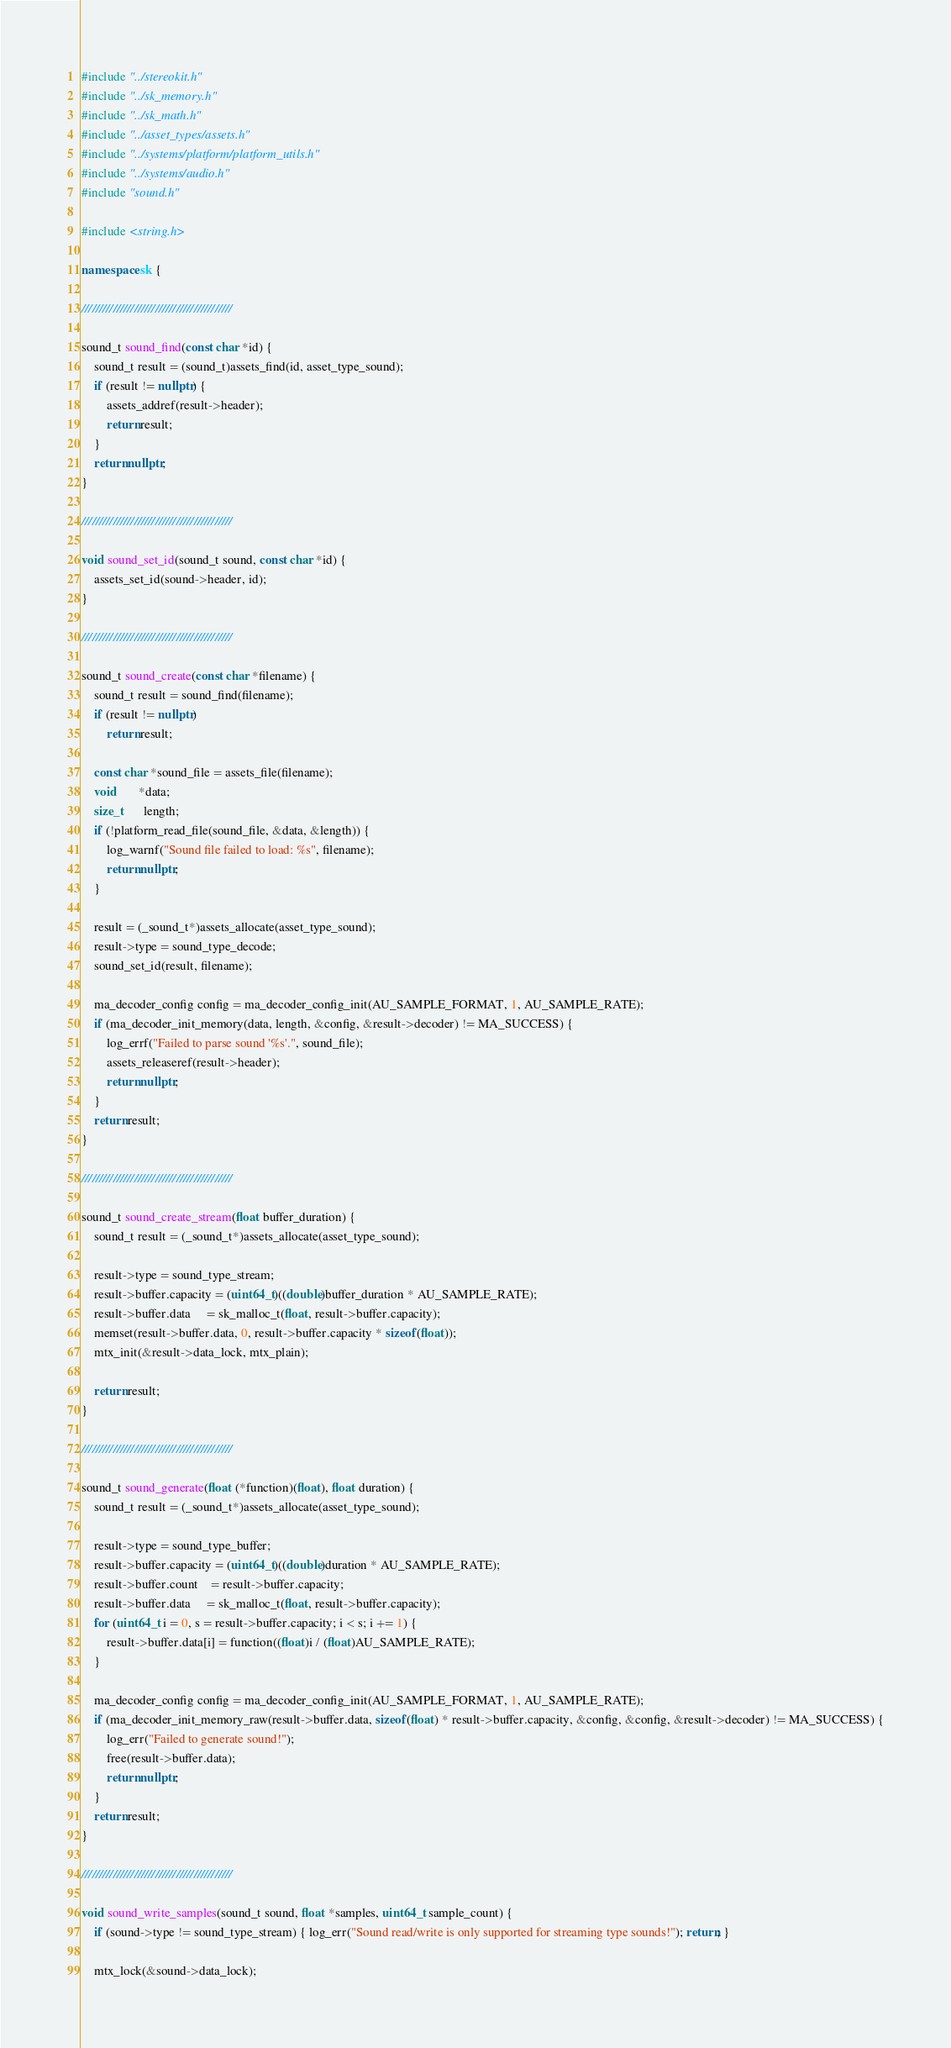Convert code to text. <code><loc_0><loc_0><loc_500><loc_500><_C++_>#include "../stereokit.h"
#include "../sk_memory.h"
#include "../sk_math.h"
#include "../asset_types/assets.h"
#include "../systems/platform/platform_utils.h"
#include "../systems/audio.h"
#include "sound.h"

#include <string.h>

namespace sk {

///////////////////////////////////////////

sound_t sound_find(const char *id) {
	sound_t result = (sound_t)assets_find(id, asset_type_sound);
	if (result != nullptr) {
		assets_addref(result->header);
		return result;
	}
	return nullptr;
}

///////////////////////////////////////////

void sound_set_id(sound_t sound, const char *id) {
	assets_set_id(sound->header, id);
}

///////////////////////////////////////////

sound_t sound_create(const char *filename) {
	sound_t result = sound_find(filename);
	if (result != nullptr)
		return result;

	const char *sound_file = assets_file(filename);
	void       *data;
	size_t      length;
	if (!platform_read_file(sound_file, &data, &length)) {
		log_warnf("Sound file failed to load: %s", filename);
		return nullptr;
	}

	result = (_sound_t*)assets_allocate(asset_type_sound);
	result->type = sound_type_decode;
	sound_set_id(result, filename);

	ma_decoder_config config = ma_decoder_config_init(AU_SAMPLE_FORMAT, 1, AU_SAMPLE_RATE);
	if (ma_decoder_init_memory(data, length, &config, &result->decoder) != MA_SUCCESS) {
		log_errf("Failed to parse sound '%s'.", sound_file);
		assets_releaseref(result->header);
		return nullptr;
	}
	return result;
}

///////////////////////////////////////////

sound_t sound_create_stream(float buffer_duration) {
	sound_t result = (_sound_t*)assets_allocate(asset_type_sound);

	result->type = sound_type_stream;
	result->buffer.capacity = (uint64_t)((double)buffer_duration * AU_SAMPLE_RATE);
	result->buffer.data     = sk_malloc_t(float, result->buffer.capacity);
	memset(result->buffer.data, 0, result->buffer.capacity * sizeof(float));
	mtx_init(&result->data_lock, mtx_plain);

	return result;
}

///////////////////////////////////////////

sound_t sound_generate(float (*function)(float), float duration) {
	sound_t result = (_sound_t*)assets_allocate(asset_type_sound);

	result->type = sound_type_buffer;
	result->buffer.capacity = (uint64_t)((double)duration * AU_SAMPLE_RATE);
	result->buffer.count    = result->buffer.capacity;
	result->buffer.data     = sk_malloc_t(float, result->buffer.capacity);
	for (uint64_t i = 0, s = result->buffer.capacity; i < s; i += 1) {
		result->buffer.data[i] = function((float)i / (float)AU_SAMPLE_RATE);
	}

	ma_decoder_config config = ma_decoder_config_init(AU_SAMPLE_FORMAT, 1, AU_SAMPLE_RATE);
	if (ma_decoder_init_memory_raw(result->buffer.data, sizeof(float) * result->buffer.capacity, &config, &config, &result->decoder) != MA_SUCCESS) {
		log_err("Failed to generate sound!");
		free(result->buffer.data);
		return nullptr;
	}
	return result;
}

///////////////////////////////////////////

void sound_write_samples(sound_t sound, float *samples, uint64_t sample_count) {
	if (sound->type != sound_type_stream) { log_err("Sound read/write is only supported for streaming type sounds!"); return; }

	mtx_lock(&sound->data_lock);</code> 